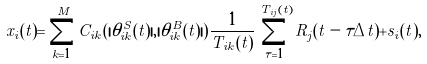<formula> <loc_0><loc_0><loc_500><loc_500>x _ { i } ( t ) = \sum _ { k = 1 } ^ { M } C _ { i k } ( | \theta _ { i k } ^ { S } ( t ) | , | \theta _ { i k } ^ { B } ( t ) | ) \frac { 1 } { T _ { i k } ( t ) } \sum _ { \tau = 1 } ^ { T _ { i j } ( t ) } R _ { j } ( t - \tau \Delta t ) + s _ { i } ( t ) ,</formula> 